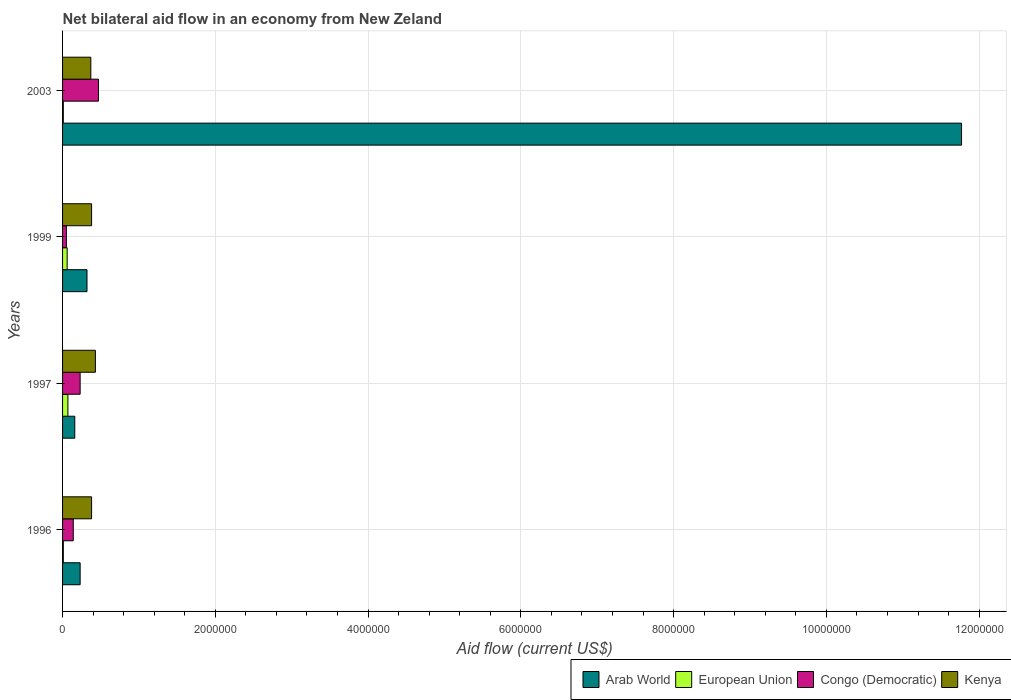How many different coloured bars are there?
Provide a short and direct response. 4. How many groups of bars are there?
Your answer should be very brief. 4. How many bars are there on the 3rd tick from the top?
Make the answer very short. 4. How many bars are there on the 3rd tick from the bottom?
Give a very brief answer. 4. What is the label of the 3rd group of bars from the top?
Your answer should be very brief. 1997. Across all years, what is the maximum net bilateral aid flow in European Union?
Make the answer very short. 7.00e+04. In which year was the net bilateral aid flow in Congo (Democratic) maximum?
Your answer should be very brief. 2003. What is the total net bilateral aid flow in Congo (Democratic) in the graph?
Your answer should be compact. 8.90e+05. What is the difference between the net bilateral aid flow in Kenya in 1999 and that in 2003?
Provide a succinct answer. 10000. What is the average net bilateral aid flow in Kenya per year?
Make the answer very short. 3.90e+05. In the year 1997, what is the difference between the net bilateral aid flow in Arab World and net bilateral aid flow in European Union?
Your answer should be very brief. 9.00e+04. In how many years, is the net bilateral aid flow in Kenya greater than 8400000 US$?
Provide a succinct answer. 0. What is the ratio of the net bilateral aid flow in Congo (Democratic) in 1997 to that in 2003?
Keep it short and to the point. 0.49. What is the difference between the highest and the lowest net bilateral aid flow in European Union?
Offer a terse response. 6.00e+04. Is it the case that in every year, the sum of the net bilateral aid flow in European Union and net bilateral aid flow in Arab World is greater than the sum of net bilateral aid flow in Congo (Democratic) and net bilateral aid flow in Kenya?
Provide a succinct answer. Yes. What does the 2nd bar from the top in 1997 represents?
Ensure brevity in your answer.  Congo (Democratic). What does the 3rd bar from the bottom in 1999 represents?
Offer a terse response. Congo (Democratic). How many bars are there?
Make the answer very short. 16. Are all the bars in the graph horizontal?
Make the answer very short. Yes. What is the difference between two consecutive major ticks on the X-axis?
Your answer should be very brief. 2.00e+06. Does the graph contain grids?
Offer a terse response. Yes. Where does the legend appear in the graph?
Give a very brief answer. Bottom right. How many legend labels are there?
Your response must be concise. 4. How are the legend labels stacked?
Ensure brevity in your answer.  Horizontal. What is the title of the graph?
Your answer should be very brief. Net bilateral aid flow in an economy from New Zeland. Does "Bahamas" appear as one of the legend labels in the graph?
Keep it short and to the point. No. What is the Aid flow (current US$) of Arab World in 1996?
Give a very brief answer. 2.30e+05. What is the Aid flow (current US$) of European Union in 1997?
Offer a terse response. 7.00e+04. What is the Aid flow (current US$) in Congo (Democratic) in 1997?
Provide a succinct answer. 2.30e+05. What is the Aid flow (current US$) of European Union in 1999?
Provide a short and direct response. 6.00e+04. What is the Aid flow (current US$) in Kenya in 1999?
Give a very brief answer. 3.80e+05. What is the Aid flow (current US$) of Arab World in 2003?
Ensure brevity in your answer.  1.18e+07. What is the Aid flow (current US$) of European Union in 2003?
Offer a terse response. 10000. What is the Aid flow (current US$) in Congo (Democratic) in 2003?
Keep it short and to the point. 4.70e+05. What is the Aid flow (current US$) of Kenya in 2003?
Your response must be concise. 3.70e+05. Across all years, what is the maximum Aid flow (current US$) in Arab World?
Make the answer very short. 1.18e+07. Across all years, what is the maximum Aid flow (current US$) of European Union?
Make the answer very short. 7.00e+04. Across all years, what is the maximum Aid flow (current US$) in Congo (Democratic)?
Provide a succinct answer. 4.70e+05. Across all years, what is the minimum Aid flow (current US$) of European Union?
Your answer should be very brief. 10000. Across all years, what is the minimum Aid flow (current US$) in Congo (Democratic)?
Ensure brevity in your answer.  5.00e+04. Across all years, what is the minimum Aid flow (current US$) of Kenya?
Keep it short and to the point. 3.70e+05. What is the total Aid flow (current US$) in Arab World in the graph?
Give a very brief answer. 1.25e+07. What is the total Aid flow (current US$) in European Union in the graph?
Provide a short and direct response. 1.50e+05. What is the total Aid flow (current US$) of Congo (Democratic) in the graph?
Your answer should be compact. 8.90e+05. What is the total Aid flow (current US$) of Kenya in the graph?
Give a very brief answer. 1.56e+06. What is the difference between the Aid flow (current US$) of Arab World in 1996 and that in 1997?
Your response must be concise. 7.00e+04. What is the difference between the Aid flow (current US$) in European Union in 1996 and that in 1997?
Your response must be concise. -6.00e+04. What is the difference between the Aid flow (current US$) of Congo (Democratic) in 1996 and that in 1997?
Offer a terse response. -9.00e+04. What is the difference between the Aid flow (current US$) of Arab World in 1996 and that in 2003?
Provide a succinct answer. -1.15e+07. What is the difference between the Aid flow (current US$) in European Union in 1996 and that in 2003?
Provide a short and direct response. 0. What is the difference between the Aid flow (current US$) in Congo (Democratic) in 1996 and that in 2003?
Give a very brief answer. -3.30e+05. What is the difference between the Aid flow (current US$) in Kenya in 1996 and that in 2003?
Provide a succinct answer. 10000. What is the difference between the Aid flow (current US$) of Arab World in 1997 and that in 1999?
Your answer should be compact. -1.60e+05. What is the difference between the Aid flow (current US$) in Kenya in 1997 and that in 1999?
Provide a succinct answer. 5.00e+04. What is the difference between the Aid flow (current US$) of Arab World in 1997 and that in 2003?
Offer a very short reply. -1.16e+07. What is the difference between the Aid flow (current US$) of Kenya in 1997 and that in 2003?
Your answer should be very brief. 6.00e+04. What is the difference between the Aid flow (current US$) in Arab World in 1999 and that in 2003?
Offer a very short reply. -1.14e+07. What is the difference between the Aid flow (current US$) of European Union in 1999 and that in 2003?
Ensure brevity in your answer.  5.00e+04. What is the difference between the Aid flow (current US$) of Congo (Democratic) in 1999 and that in 2003?
Provide a succinct answer. -4.20e+05. What is the difference between the Aid flow (current US$) in Arab World in 1996 and the Aid flow (current US$) in European Union in 1997?
Ensure brevity in your answer.  1.60e+05. What is the difference between the Aid flow (current US$) of Arab World in 1996 and the Aid flow (current US$) of Kenya in 1997?
Offer a terse response. -2.00e+05. What is the difference between the Aid flow (current US$) of European Union in 1996 and the Aid flow (current US$) of Kenya in 1997?
Make the answer very short. -4.20e+05. What is the difference between the Aid flow (current US$) of Congo (Democratic) in 1996 and the Aid flow (current US$) of Kenya in 1997?
Provide a short and direct response. -2.90e+05. What is the difference between the Aid flow (current US$) in Arab World in 1996 and the Aid flow (current US$) in Congo (Democratic) in 1999?
Your answer should be compact. 1.80e+05. What is the difference between the Aid flow (current US$) in Arab World in 1996 and the Aid flow (current US$) in Kenya in 1999?
Give a very brief answer. -1.50e+05. What is the difference between the Aid flow (current US$) of European Union in 1996 and the Aid flow (current US$) of Kenya in 1999?
Keep it short and to the point. -3.70e+05. What is the difference between the Aid flow (current US$) in Congo (Democratic) in 1996 and the Aid flow (current US$) in Kenya in 1999?
Provide a short and direct response. -2.40e+05. What is the difference between the Aid flow (current US$) in Arab World in 1996 and the Aid flow (current US$) in European Union in 2003?
Keep it short and to the point. 2.20e+05. What is the difference between the Aid flow (current US$) of Arab World in 1996 and the Aid flow (current US$) of Congo (Democratic) in 2003?
Provide a short and direct response. -2.40e+05. What is the difference between the Aid flow (current US$) in Arab World in 1996 and the Aid flow (current US$) in Kenya in 2003?
Give a very brief answer. -1.40e+05. What is the difference between the Aid flow (current US$) of European Union in 1996 and the Aid flow (current US$) of Congo (Democratic) in 2003?
Your answer should be compact. -4.60e+05. What is the difference between the Aid flow (current US$) of European Union in 1996 and the Aid flow (current US$) of Kenya in 2003?
Keep it short and to the point. -3.60e+05. What is the difference between the Aid flow (current US$) of Congo (Democratic) in 1996 and the Aid flow (current US$) of Kenya in 2003?
Offer a very short reply. -2.30e+05. What is the difference between the Aid flow (current US$) in Arab World in 1997 and the Aid flow (current US$) in Congo (Democratic) in 1999?
Keep it short and to the point. 1.10e+05. What is the difference between the Aid flow (current US$) of European Union in 1997 and the Aid flow (current US$) of Congo (Democratic) in 1999?
Your answer should be compact. 2.00e+04. What is the difference between the Aid flow (current US$) of European Union in 1997 and the Aid flow (current US$) of Kenya in 1999?
Make the answer very short. -3.10e+05. What is the difference between the Aid flow (current US$) of Arab World in 1997 and the Aid flow (current US$) of European Union in 2003?
Provide a succinct answer. 1.50e+05. What is the difference between the Aid flow (current US$) in Arab World in 1997 and the Aid flow (current US$) in Congo (Democratic) in 2003?
Ensure brevity in your answer.  -3.10e+05. What is the difference between the Aid flow (current US$) of European Union in 1997 and the Aid flow (current US$) of Congo (Democratic) in 2003?
Give a very brief answer. -4.00e+05. What is the difference between the Aid flow (current US$) of European Union in 1997 and the Aid flow (current US$) of Kenya in 2003?
Provide a short and direct response. -3.00e+05. What is the difference between the Aid flow (current US$) in Arab World in 1999 and the Aid flow (current US$) in European Union in 2003?
Your response must be concise. 3.10e+05. What is the difference between the Aid flow (current US$) in Arab World in 1999 and the Aid flow (current US$) in Congo (Democratic) in 2003?
Ensure brevity in your answer.  -1.50e+05. What is the difference between the Aid flow (current US$) of Arab World in 1999 and the Aid flow (current US$) of Kenya in 2003?
Give a very brief answer. -5.00e+04. What is the difference between the Aid flow (current US$) of European Union in 1999 and the Aid flow (current US$) of Congo (Democratic) in 2003?
Keep it short and to the point. -4.10e+05. What is the difference between the Aid flow (current US$) of European Union in 1999 and the Aid flow (current US$) of Kenya in 2003?
Provide a succinct answer. -3.10e+05. What is the difference between the Aid flow (current US$) of Congo (Democratic) in 1999 and the Aid flow (current US$) of Kenya in 2003?
Your answer should be very brief. -3.20e+05. What is the average Aid flow (current US$) of Arab World per year?
Provide a short and direct response. 3.12e+06. What is the average Aid flow (current US$) of European Union per year?
Provide a succinct answer. 3.75e+04. What is the average Aid flow (current US$) in Congo (Democratic) per year?
Your response must be concise. 2.22e+05. What is the average Aid flow (current US$) of Kenya per year?
Your answer should be compact. 3.90e+05. In the year 1996, what is the difference between the Aid flow (current US$) of Arab World and Aid flow (current US$) of Kenya?
Provide a short and direct response. -1.50e+05. In the year 1996, what is the difference between the Aid flow (current US$) in European Union and Aid flow (current US$) in Congo (Democratic)?
Make the answer very short. -1.30e+05. In the year 1996, what is the difference between the Aid flow (current US$) in European Union and Aid flow (current US$) in Kenya?
Make the answer very short. -3.70e+05. In the year 1997, what is the difference between the Aid flow (current US$) of Arab World and Aid flow (current US$) of European Union?
Your answer should be compact. 9.00e+04. In the year 1997, what is the difference between the Aid flow (current US$) in Arab World and Aid flow (current US$) in Kenya?
Give a very brief answer. -2.70e+05. In the year 1997, what is the difference between the Aid flow (current US$) in European Union and Aid flow (current US$) in Congo (Democratic)?
Ensure brevity in your answer.  -1.60e+05. In the year 1997, what is the difference between the Aid flow (current US$) of European Union and Aid flow (current US$) of Kenya?
Keep it short and to the point. -3.60e+05. In the year 1997, what is the difference between the Aid flow (current US$) of Congo (Democratic) and Aid flow (current US$) of Kenya?
Your answer should be compact. -2.00e+05. In the year 1999, what is the difference between the Aid flow (current US$) of Arab World and Aid flow (current US$) of European Union?
Offer a terse response. 2.60e+05. In the year 1999, what is the difference between the Aid flow (current US$) of European Union and Aid flow (current US$) of Kenya?
Provide a succinct answer. -3.20e+05. In the year 1999, what is the difference between the Aid flow (current US$) in Congo (Democratic) and Aid flow (current US$) in Kenya?
Offer a very short reply. -3.30e+05. In the year 2003, what is the difference between the Aid flow (current US$) of Arab World and Aid flow (current US$) of European Union?
Your answer should be very brief. 1.18e+07. In the year 2003, what is the difference between the Aid flow (current US$) in Arab World and Aid flow (current US$) in Congo (Democratic)?
Your response must be concise. 1.13e+07. In the year 2003, what is the difference between the Aid flow (current US$) in Arab World and Aid flow (current US$) in Kenya?
Your answer should be compact. 1.14e+07. In the year 2003, what is the difference between the Aid flow (current US$) of European Union and Aid flow (current US$) of Congo (Democratic)?
Offer a very short reply. -4.60e+05. In the year 2003, what is the difference between the Aid flow (current US$) in European Union and Aid flow (current US$) in Kenya?
Provide a short and direct response. -3.60e+05. In the year 2003, what is the difference between the Aid flow (current US$) of Congo (Democratic) and Aid flow (current US$) of Kenya?
Your answer should be very brief. 1.00e+05. What is the ratio of the Aid flow (current US$) in Arab World in 1996 to that in 1997?
Ensure brevity in your answer.  1.44. What is the ratio of the Aid flow (current US$) in European Union in 1996 to that in 1997?
Provide a succinct answer. 0.14. What is the ratio of the Aid flow (current US$) in Congo (Democratic) in 1996 to that in 1997?
Your response must be concise. 0.61. What is the ratio of the Aid flow (current US$) of Kenya in 1996 to that in 1997?
Provide a succinct answer. 0.88. What is the ratio of the Aid flow (current US$) of Arab World in 1996 to that in 1999?
Your response must be concise. 0.72. What is the ratio of the Aid flow (current US$) of Congo (Democratic) in 1996 to that in 1999?
Provide a succinct answer. 2.8. What is the ratio of the Aid flow (current US$) in Kenya in 1996 to that in 1999?
Make the answer very short. 1. What is the ratio of the Aid flow (current US$) in Arab World in 1996 to that in 2003?
Your response must be concise. 0.02. What is the ratio of the Aid flow (current US$) of Congo (Democratic) in 1996 to that in 2003?
Keep it short and to the point. 0.3. What is the ratio of the Aid flow (current US$) in Arab World in 1997 to that in 1999?
Keep it short and to the point. 0.5. What is the ratio of the Aid flow (current US$) in Congo (Democratic) in 1997 to that in 1999?
Your response must be concise. 4.6. What is the ratio of the Aid flow (current US$) of Kenya in 1997 to that in 1999?
Your answer should be compact. 1.13. What is the ratio of the Aid flow (current US$) in Arab World in 1997 to that in 2003?
Keep it short and to the point. 0.01. What is the ratio of the Aid flow (current US$) in European Union in 1997 to that in 2003?
Offer a very short reply. 7. What is the ratio of the Aid flow (current US$) in Congo (Democratic) in 1997 to that in 2003?
Offer a very short reply. 0.49. What is the ratio of the Aid flow (current US$) of Kenya in 1997 to that in 2003?
Your answer should be very brief. 1.16. What is the ratio of the Aid flow (current US$) in Arab World in 1999 to that in 2003?
Your answer should be very brief. 0.03. What is the ratio of the Aid flow (current US$) of European Union in 1999 to that in 2003?
Provide a succinct answer. 6. What is the ratio of the Aid flow (current US$) in Congo (Democratic) in 1999 to that in 2003?
Give a very brief answer. 0.11. What is the difference between the highest and the second highest Aid flow (current US$) of Arab World?
Your response must be concise. 1.14e+07. What is the difference between the highest and the second highest Aid flow (current US$) of European Union?
Offer a terse response. 10000. What is the difference between the highest and the second highest Aid flow (current US$) of Kenya?
Your response must be concise. 5.00e+04. What is the difference between the highest and the lowest Aid flow (current US$) of Arab World?
Your response must be concise. 1.16e+07. What is the difference between the highest and the lowest Aid flow (current US$) in European Union?
Keep it short and to the point. 6.00e+04. What is the difference between the highest and the lowest Aid flow (current US$) of Congo (Democratic)?
Offer a terse response. 4.20e+05. 